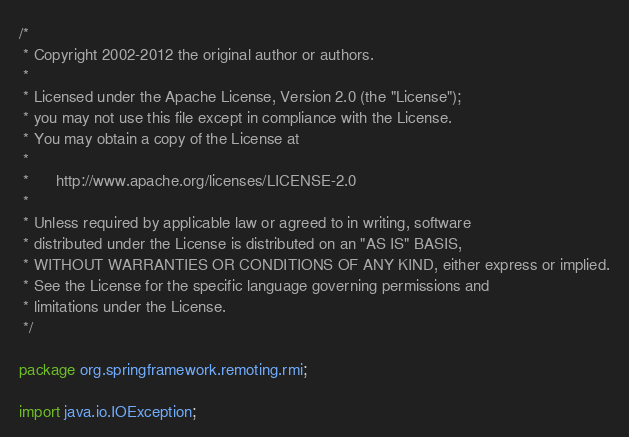Convert code to text. <code><loc_0><loc_0><loc_500><loc_500><_Java_>/*
 * Copyright 2002-2012 the original author or authors.
 *
 * Licensed under the Apache License, Version 2.0 (the "License");
 * you may not use this file except in compliance with the License.
 * You may obtain a copy of the License at
 *
 *      http://www.apache.org/licenses/LICENSE-2.0
 *
 * Unless required by applicable law or agreed to in writing, software
 * distributed under the License is distributed on an "AS IS" BASIS,
 * WITHOUT WARRANTIES OR CONDITIONS OF ANY KIND, either express or implied.
 * See the License for the specific language governing permissions and
 * limitations under the License.
 */

package org.springframework.remoting.rmi;

import java.io.IOException;</code> 